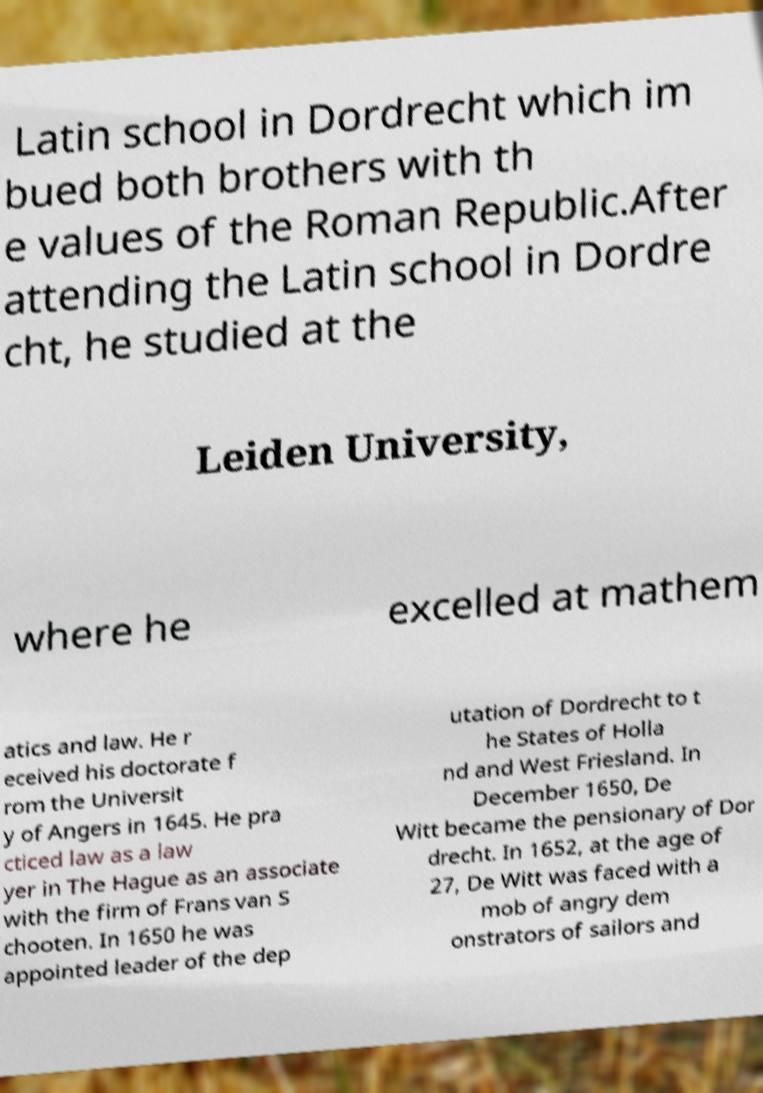Can you accurately transcribe the text from the provided image for me? Latin school in Dordrecht which im bued both brothers with th e values of the Roman Republic.After attending the Latin school in Dordre cht, he studied at the Leiden University, where he excelled at mathem atics and law. He r eceived his doctorate f rom the Universit y of Angers in 1645. He pra cticed law as a law yer in The Hague as an associate with the firm of Frans van S chooten. In 1650 he was appointed leader of the dep utation of Dordrecht to t he States of Holla nd and West Friesland. In December 1650, De Witt became the pensionary of Dor drecht. In 1652, at the age of 27, De Witt was faced with a mob of angry dem onstrators of sailors and 